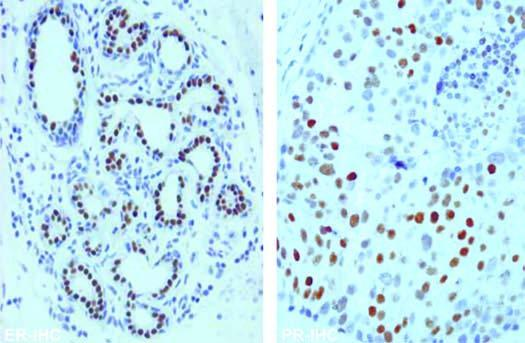how do the tumour cells show nuclear positivity?
Answer the question using a single word or phrase. With er and pr antibody immunostains 